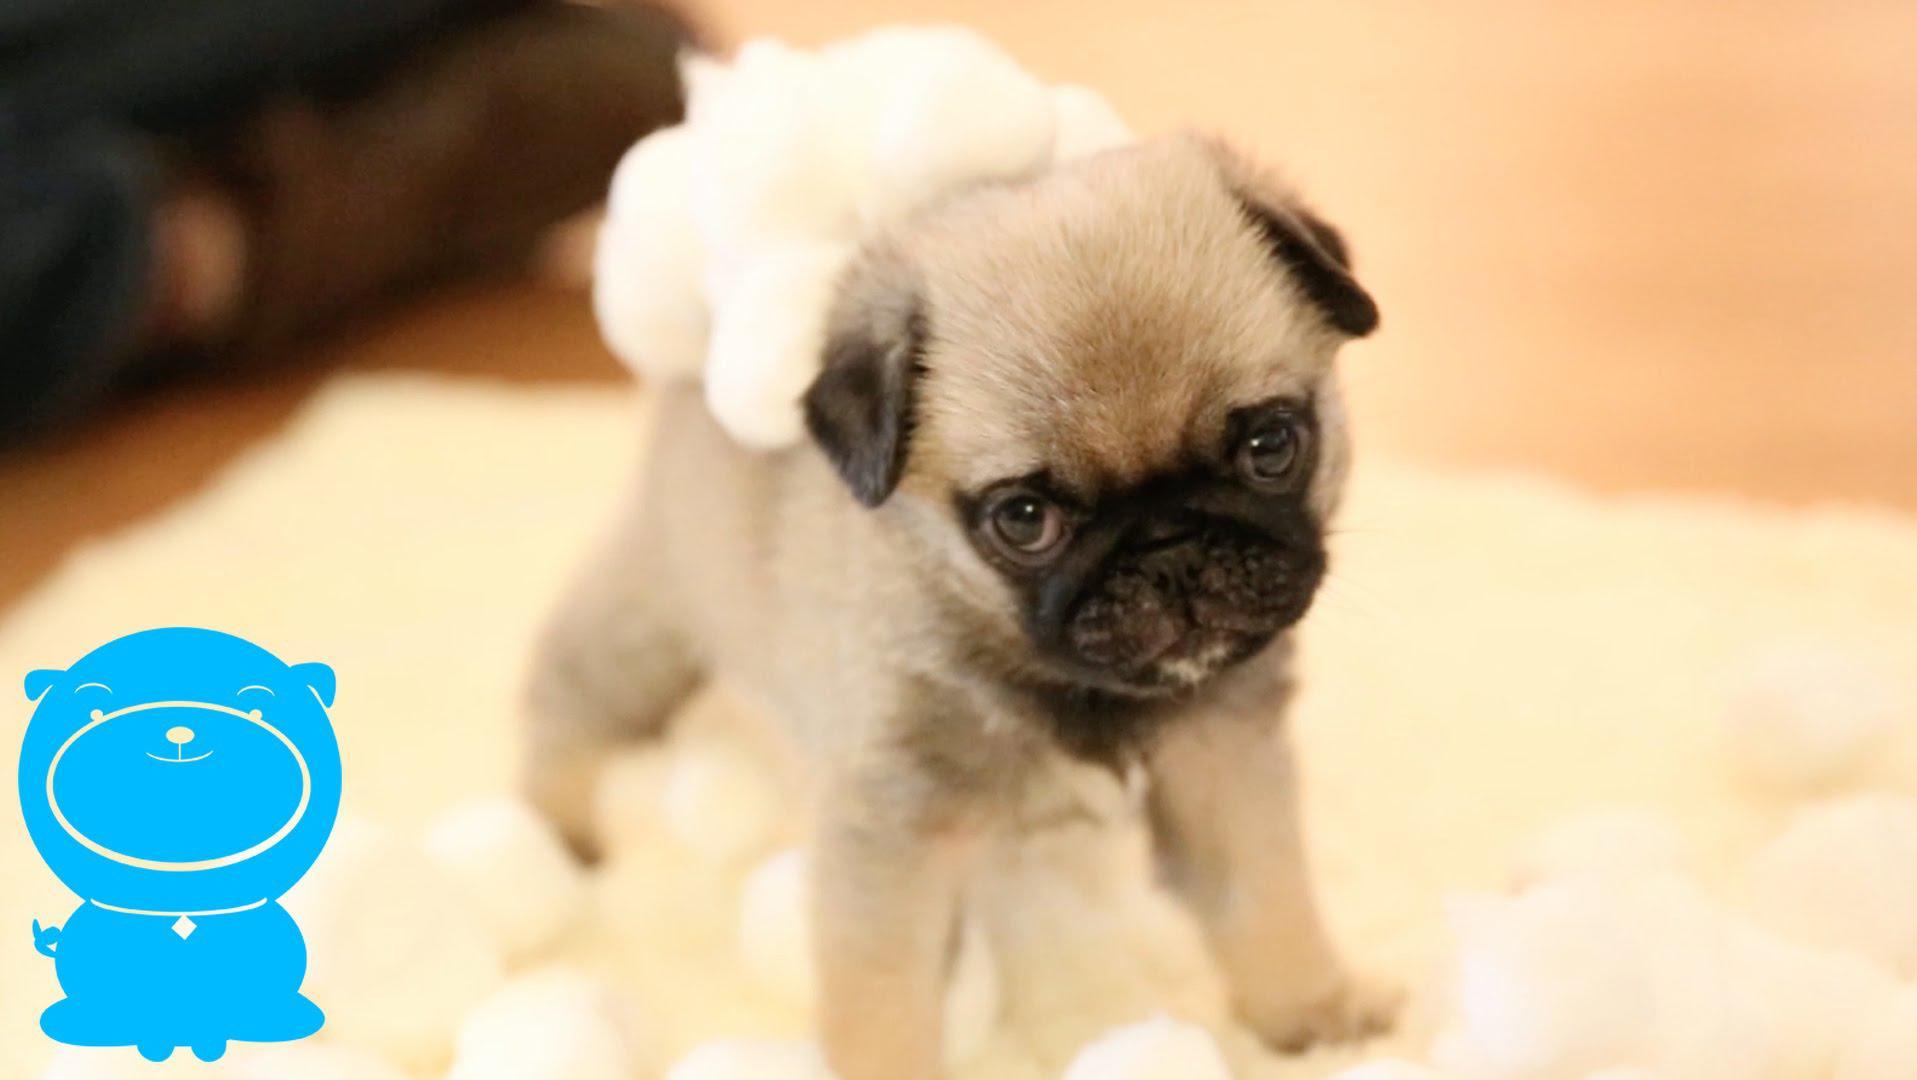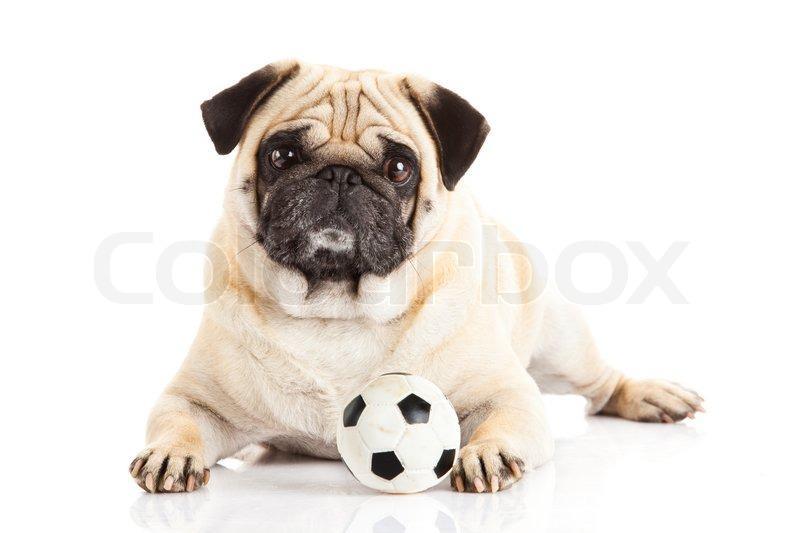The first image is the image on the left, the second image is the image on the right. Evaluate the accuracy of this statement regarding the images: "In one image a dog is with a soccer ball toy.". Is it true? Answer yes or no. Yes. The first image is the image on the left, the second image is the image on the right. For the images shown, is this caption "The dog on the right is posing with a black and white ball" true? Answer yes or no. Yes. 